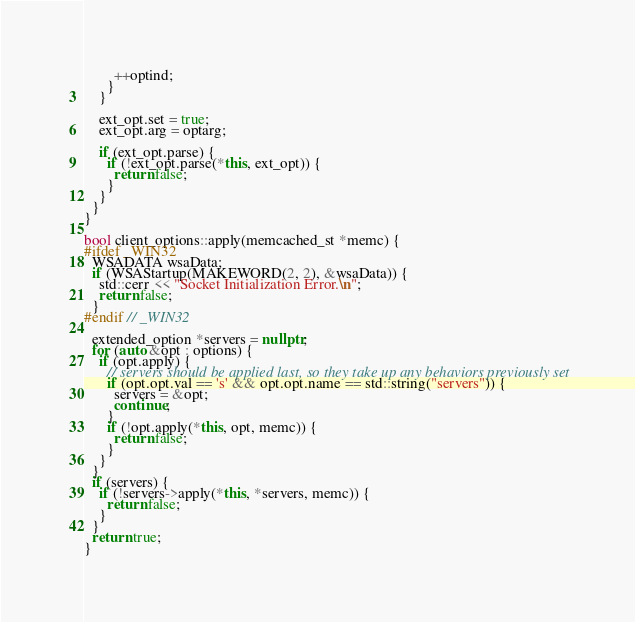Convert code to text. <code><loc_0><loc_0><loc_500><loc_500><_C++_>        ++optind;
      }
    }

    ext_opt.set = true;
    ext_opt.arg = optarg;

    if (ext_opt.parse) {
      if (!ext_opt.parse(*this, ext_opt)) {
        return false;
      }
    }
  }
}

bool client_options::apply(memcached_st *memc) {
#ifdef _WIN32
  WSADATA wsaData;
  if (WSAStartup(MAKEWORD(2, 2), &wsaData)) {
    std::cerr << "Socket Initialization Error.\n";
    return false;
  }
#endif // _WIN32

  extended_option *servers = nullptr;
  for (auto &opt : options) {
    if (opt.apply) {
      // servers should be applied last, so they take up any behaviors previously set
      if (opt.opt.val == 's' && opt.opt.name == std::string("servers")) {
        servers = &opt;
        continue;
      }
      if (!opt.apply(*this, opt, memc)) {
        return false;
      }
    }
  }
  if (servers) {
    if (!servers->apply(*this, *servers, memc)) {
      return false;
    }
  }
  return true;
}
</code> 